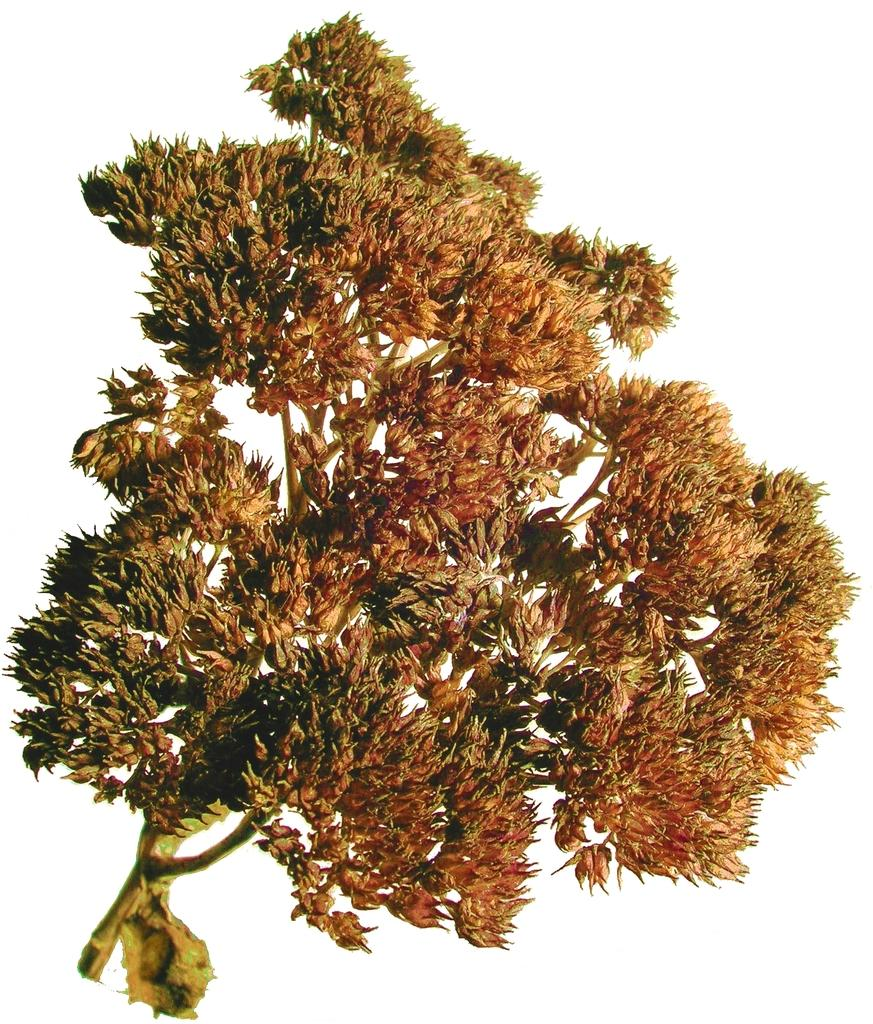What is the main subject of the image? The main subject of the image is a branch of a plant. What color is the background of the image? The background of the image is white. What type of print is visible on the shelf in the image? There is no shelf or print present in the image, as the main subject is a branch of a plant and the background is white. 